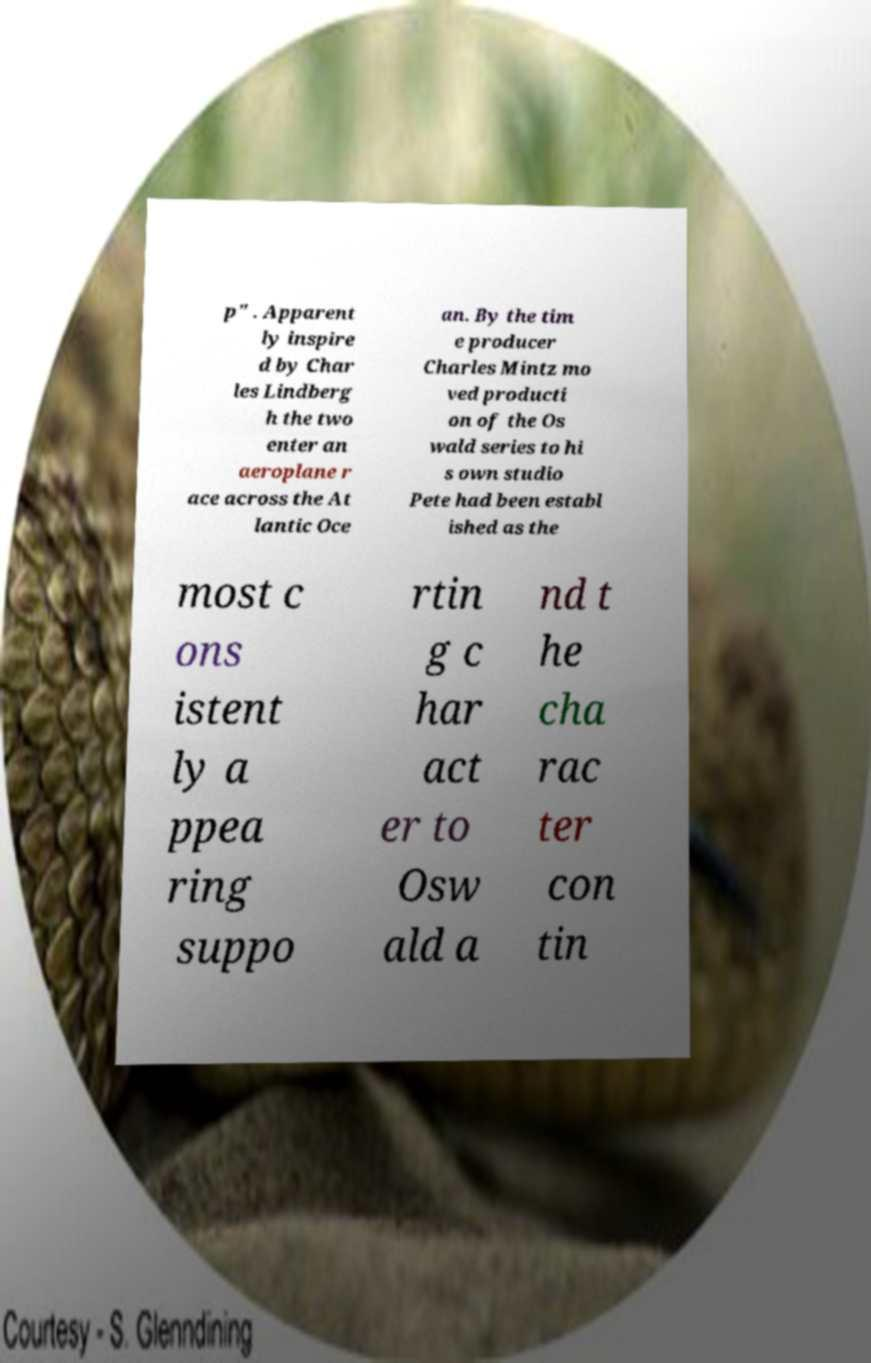Can you read and provide the text displayed in the image?This photo seems to have some interesting text. Can you extract and type it out for me? p" . Apparent ly inspire d by Char les Lindberg h the two enter an aeroplane r ace across the At lantic Oce an. By the tim e producer Charles Mintz mo ved producti on of the Os wald series to hi s own studio Pete had been establ ished as the most c ons istent ly a ppea ring suppo rtin g c har act er to Osw ald a nd t he cha rac ter con tin 